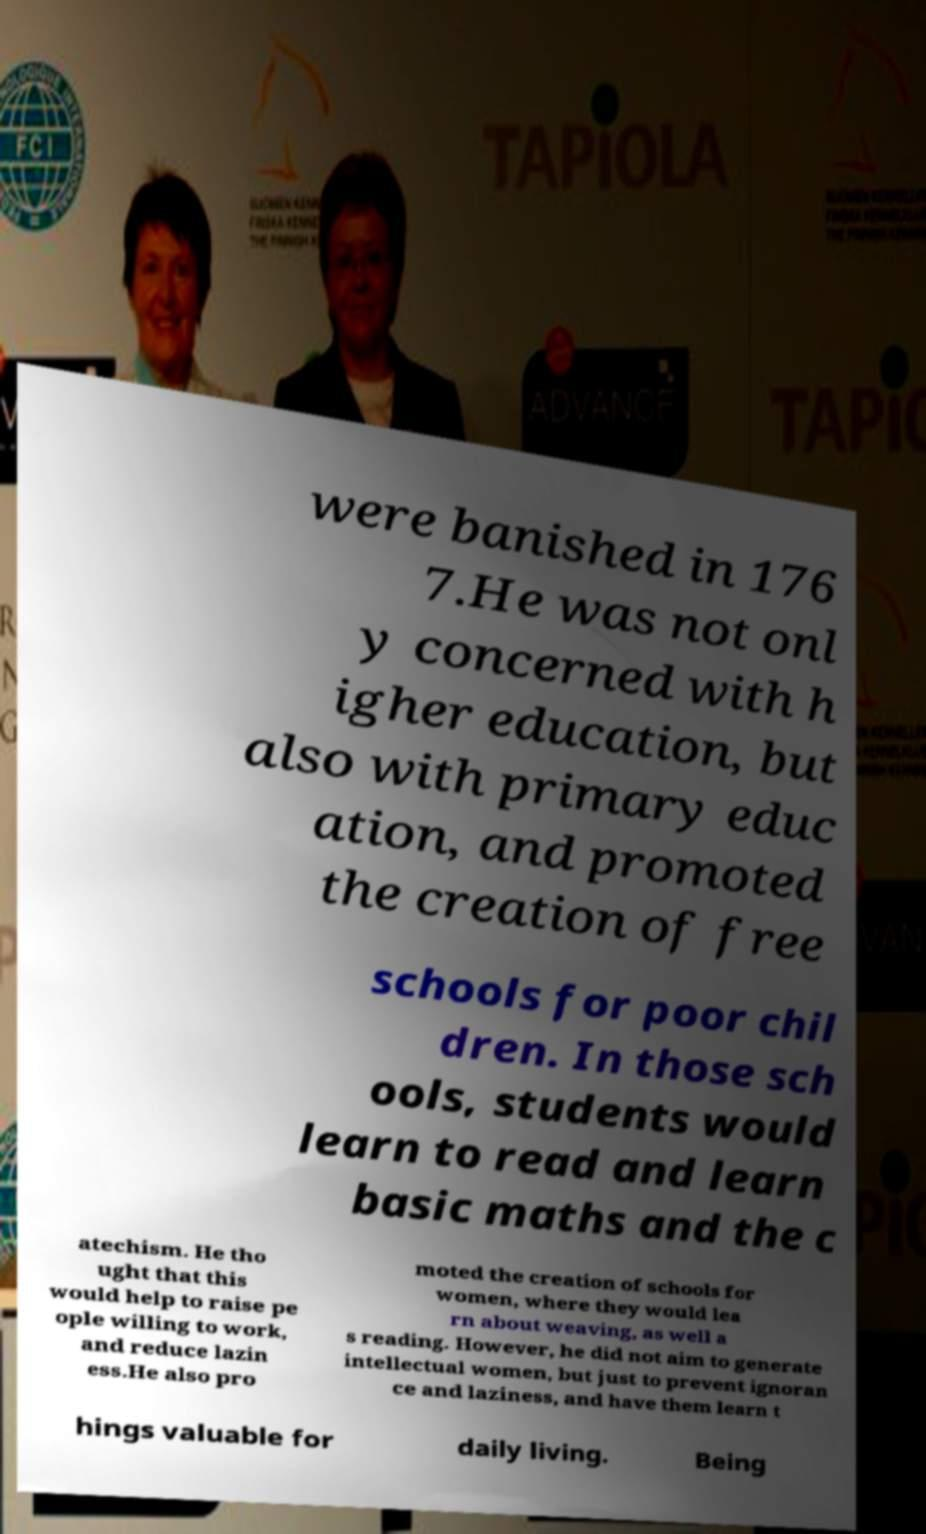Can you accurately transcribe the text from the provided image for me? were banished in 176 7.He was not onl y concerned with h igher education, but also with primary educ ation, and promoted the creation of free schools for poor chil dren. In those sch ools, students would learn to read and learn basic maths and the c atechism. He tho ught that this would help to raise pe ople willing to work, and reduce lazin ess.He also pro moted the creation of schools for women, where they would lea rn about weaving, as well a s reading. However, he did not aim to generate intellectual women, but just to prevent ignoran ce and laziness, and have them learn t hings valuable for daily living. Being 